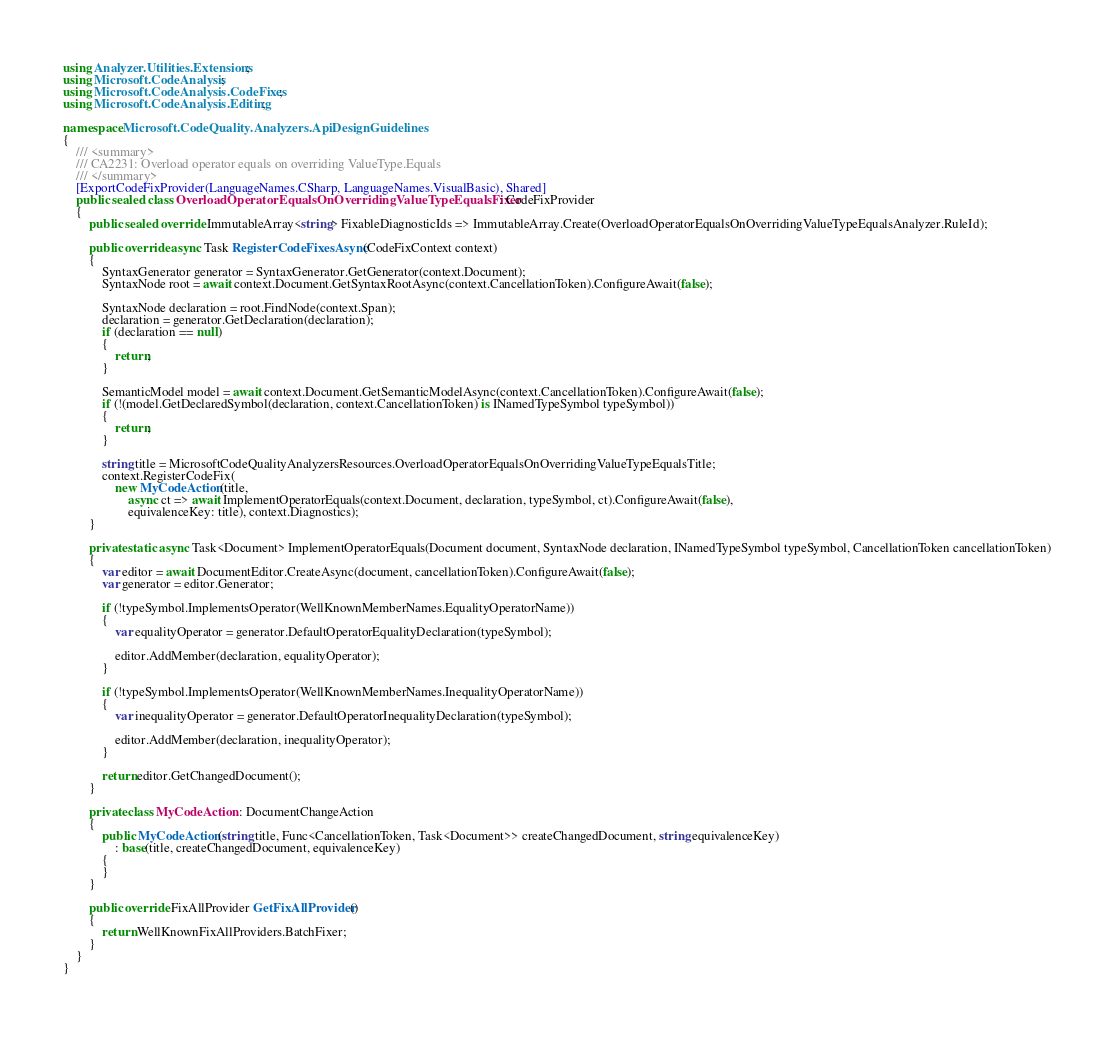Convert code to text. <code><loc_0><loc_0><loc_500><loc_500><_C#_>using Analyzer.Utilities.Extensions;
using Microsoft.CodeAnalysis;
using Microsoft.CodeAnalysis.CodeFixes;
using Microsoft.CodeAnalysis.Editing;

namespace Microsoft.CodeQuality.Analyzers.ApiDesignGuidelines
{
    /// <summary>
    /// CA2231: Overload operator equals on overriding ValueType.Equals
    /// </summary>
    [ExportCodeFixProvider(LanguageNames.CSharp, LanguageNames.VisualBasic), Shared]
    public sealed class OverloadOperatorEqualsOnOverridingValueTypeEqualsFixer : CodeFixProvider
    {
        public sealed override ImmutableArray<string> FixableDiagnosticIds => ImmutableArray.Create(OverloadOperatorEqualsOnOverridingValueTypeEqualsAnalyzer.RuleId);

        public override async Task RegisterCodeFixesAsync(CodeFixContext context)
        {
            SyntaxGenerator generator = SyntaxGenerator.GetGenerator(context.Document);
            SyntaxNode root = await context.Document.GetSyntaxRootAsync(context.CancellationToken).ConfigureAwait(false);

            SyntaxNode declaration = root.FindNode(context.Span);
            declaration = generator.GetDeclaration(declaration);
            if (declaration == null)
            {
                return;
            }

            SemanticModel model = await context.Document.GetSemanticModelAsync(context.CancellationToken).ConfigureAwait(false);
            if (!(model.GetDeclaredSymbol(declaration, context.CancellationToken) is INamedTypeSymbol typeSymbol))
            {
                return;
            }

            string title = MicrosoftCodeQualityAnalyzersResources.OverloadOperatorEqualsOnOverridingValueTypeEqualsTitle;
            context.RegisterCodeFix(
                new MyCodeAction(title,
                    async ct => await ImplementOperatorEquals(context.Document, declaration, typeSymbol, ct).ConfigureAwait(false),
                    equivalenceKey: title), context.Diagnostics);
        }

        private static async Task<Document> ImplementOperatorEquals(Document document, SyntaxNode declaration, INamedTypeSymbol typeSymbol, CancellationToken cancellationToken)
        {
            var editor = await DocumentEditor.CreateAsync(document, cancellationToken).ConfigureAwait(false);
            var generator = editor.Generator;

            if (!typeSymbol.ImplementsOperator(WellKnownMemberNames.EqualityOperatorName))
            {
                var equalityOperator = generator.DefaultOperatorEqualityDeclaration(typeSymbol);

                editor.AddMember(declaration, equalityOperator);
            }

            if (!typeSymbol.ImplementsOperator(WellKnownMemberNames.InequalityOperatorName))
            {
                var inequalityOperator = generator.DefaultOperatorInequalityDeclaration(typeSymbol);

                editor.AddMember(declaration, inequalityOperator);
            }

            return editor.GetChangedDocument();
        }

        private class MyCodeAction : DocumentChangeAction
        {
            public MyCodeAction(string title, Func<CancellationToken, Task<Document>> createChangedDocument, string equivalenceKey)
                : base(title, createChangedDocument, equivalenceKey)
            {
            }
        }

        public override FixAllProvider GetFixAllProvider()
        {
            return WellKnownFixAllProviders.BatchFixer;
        }
    }
}
</code> 